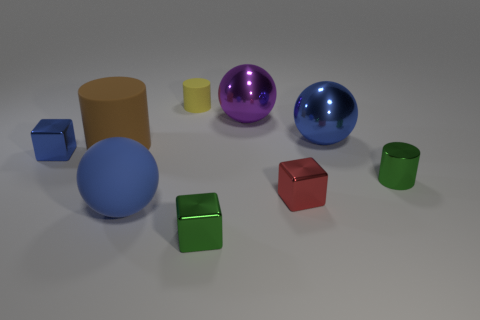Subtract all blocks. How many objects are left? 6 Add 9 big cyan rubber spheres. How many big cyan rubber spheres exist? 9 Subtract 0 brown balls. How many objects are left? 9 Subtract all red blocks. Subtract all metal cylinders. How many objects are left? 7 Add 1 big purple metallic things. How many big purple metallic things are left? 2 